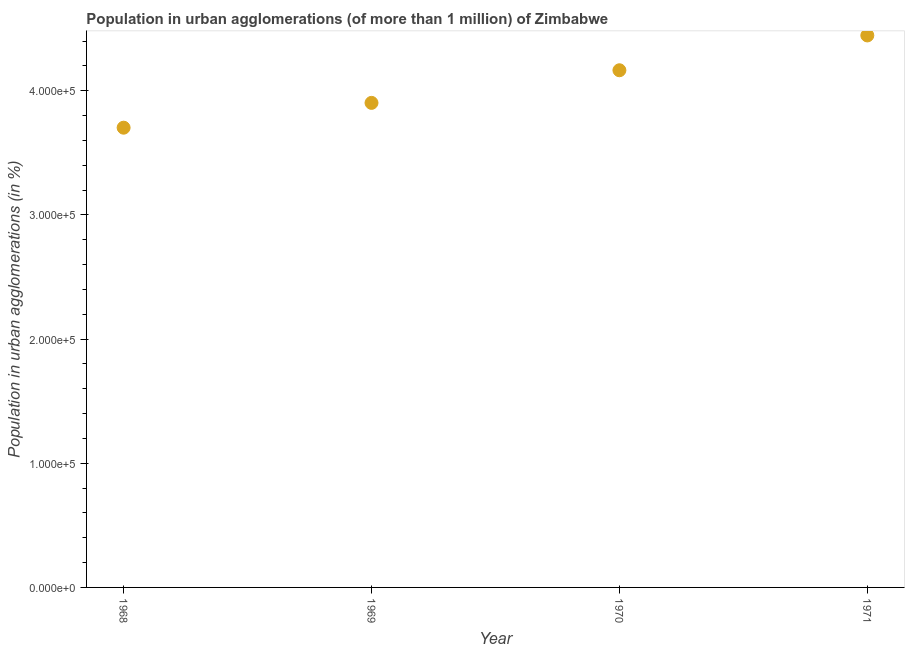What is the population in urban agglomerations in 1968?
Your answer should be compact. 3.70e+05. Across all years, what is the maximum population in urban agglomerations?
Your answer should be compact. 4.45e+05. Across all years, what is the minimum population in urban agglomerations?
Make the answer very short. 3.70e+05. In which year was the population in urban agglomerations minimum?
Provide a succinct answer. 1968. What is the sum of the population in urban agglomerations?
Your answer should be very brief. 1.62e+06. What is the difference between the population in urban agglomerations in 1968 and 1971?
Offer a terse response. -7.43e+04. What is the average population in urban agglomerations per year?
Keep it short and to the point. 4.05e+05. What is the median population in urban agglomerations?
Provide a succinct answer. 4.03e+05. Do a majority of the years between 1969 and 1968 (inclusive) have population in urban agglomerations greater than 40000 %?
Your answer should be very brief. No. What is the ratio of the population in urban agglomerations in 1969 to that in 1971?
Ensure brevity in your answer.  0.88. What is the difference between the highest and the second highest population in urban agglomerations?
Offer a very short reply. 2.80e+04. Is the sum of the population in urban agglomerations in 1970 and 1971 greater than the maximum population in urban agglomerations across all years?
Provide a succinct answer. Yes. What is the difference between the highest and the lowest population in urban agglomerations?
Offer a very short reply. 7.43e+04. Does the population in urban agglomerations monotonically increase over the years?
Keep it short and to the point. Yes. How many dotlines are there?
Provide a succinct answer. 1. Are the values on the major ticks of Y-axis written in scientific E-notation?
Provide a short and direct response. Yes. Does the graph contain any zero values?
Make the answer very short. No. Does the graph contain grids?
Make the answer very short. No. What is the title of the graph?
Offer a terse response. Population in urban agglomerations (of more than 1 million) of Zimbabwe. What is the label or title of the X-axis?
Your answer should be compact. Year. What is the label or title of the Y-axis?
Give a very brief answer. Population in urban agglomerations (in %). What is the Population in urban agglomerations (in %) in 1968?
Keep it short and to the point. 3.70e+05. What is the Population in urban agglomerations (in %) in 1969?
Offer a very short reply. 3.90e+05. What is the Population in urban agglomerations (in %) in 1970?
Ensure brevity in your answer.  4.17e+05. What is the Population in urban agglomerations (in %) in 1971?
Ensure brevity in your answer.  4.45e+05. What is the difference between the Population in urban agglomerations (in %) in 1968 and 1969?
Provide a succinct answer. -2.00e+04. What is the difference between the Population in urban agglomerations (in %) in 1968 and 1970?
Offer a terse response. -4.63e+04. What is the difference between the Population in urban agglomerations (in %) in 1968 and 1971?
Offer a very short reply. -7.43e+04. What is the difference between the Population in urban agglomerations (in %) in 1969 and 1970?
Give a very brief answer. -2.63e+04. What is the difference between the Population in urban agglomerations (in %) in 1969 and 1971?
Offer a very short reply. -5.43e+04. What is the difference between the Population in urban agglomerations (in %) in 1970 and 1971?
Keep it short and to the point. -2.80e+04. What is the ratio of the Population in urban agglomerations (in %) in 1968 to that in 1969?
Keep it short and to the point. 0.95. What is the ratio of the Population in urban agglomerations (in %) in 1968 to that in 1970?
Your answer should be compact. 0.89. What is the ratio of the Population in urban agglomerations (in %) in 1968 to that in 1971?
Offer a terse response. 0.83. What is the ratio of the Population in urban agglomerations (in %) in 1969 to that in 1970?
Your answer should be very brief. 0.94. What is the ratio of the Population in urban agglomerations (in %) in 1969 to that in 1971?
Offer a very short reply. 0.88. What is the ratio of the Population in urban agglomerations (in %) in 1970 to that in 1971?
Keep it short and to the point. 0.94. 